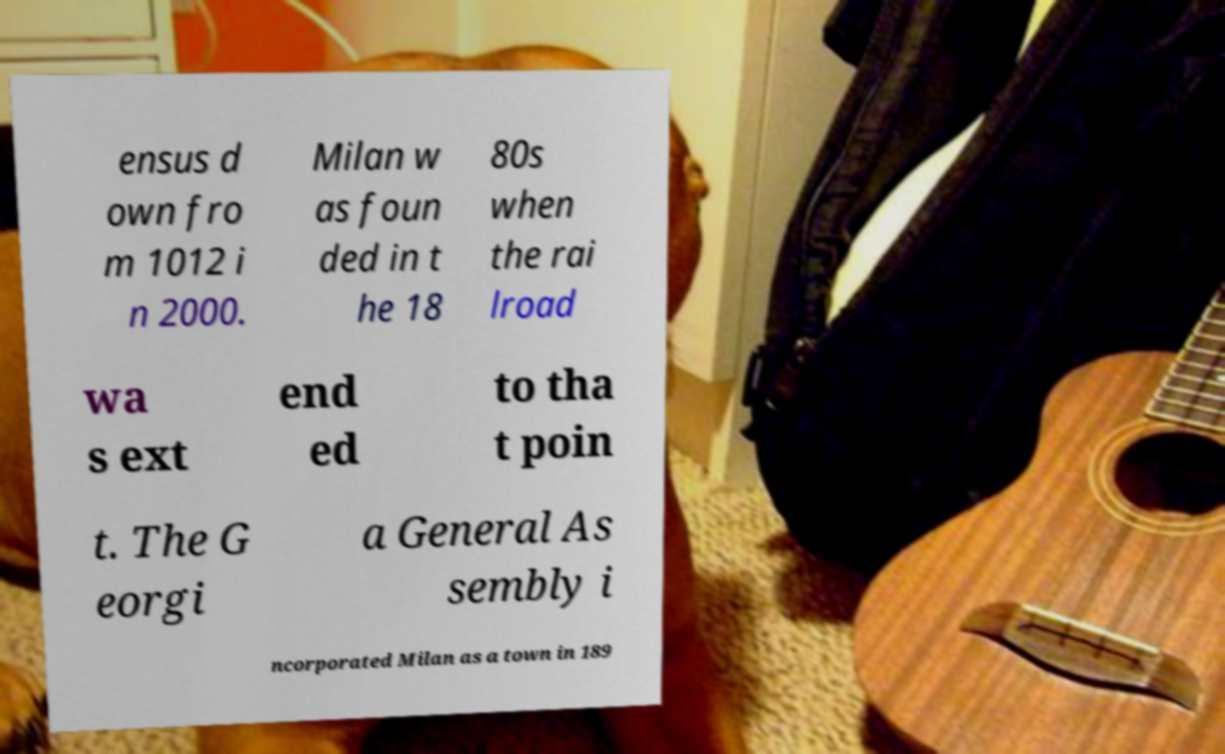Please identify and transcribe the text found in this image. ensus d own fro m 1012 i n 2000. Milan w as foun ded in t he 18 80s when the rai lroad wa s ext end ed to tha t poin t. The G eorgi a General As sembly i ncorporated Milan as a town in 189 